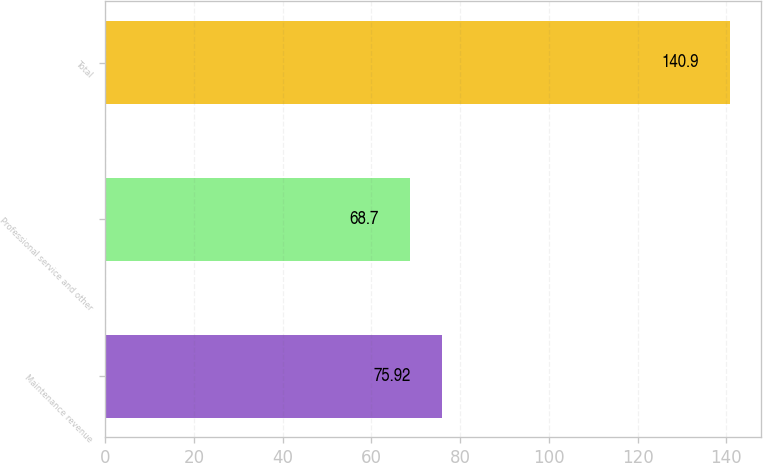<chart> <loc_0><loc_0><loc_500><loc_500><bar_chart><fcel>Maintenance revenue<fcel>Professional service and other<fcel>Total<nl><fcel>75.92<fcel>68.7<fcel>140.9<nl></chart> 